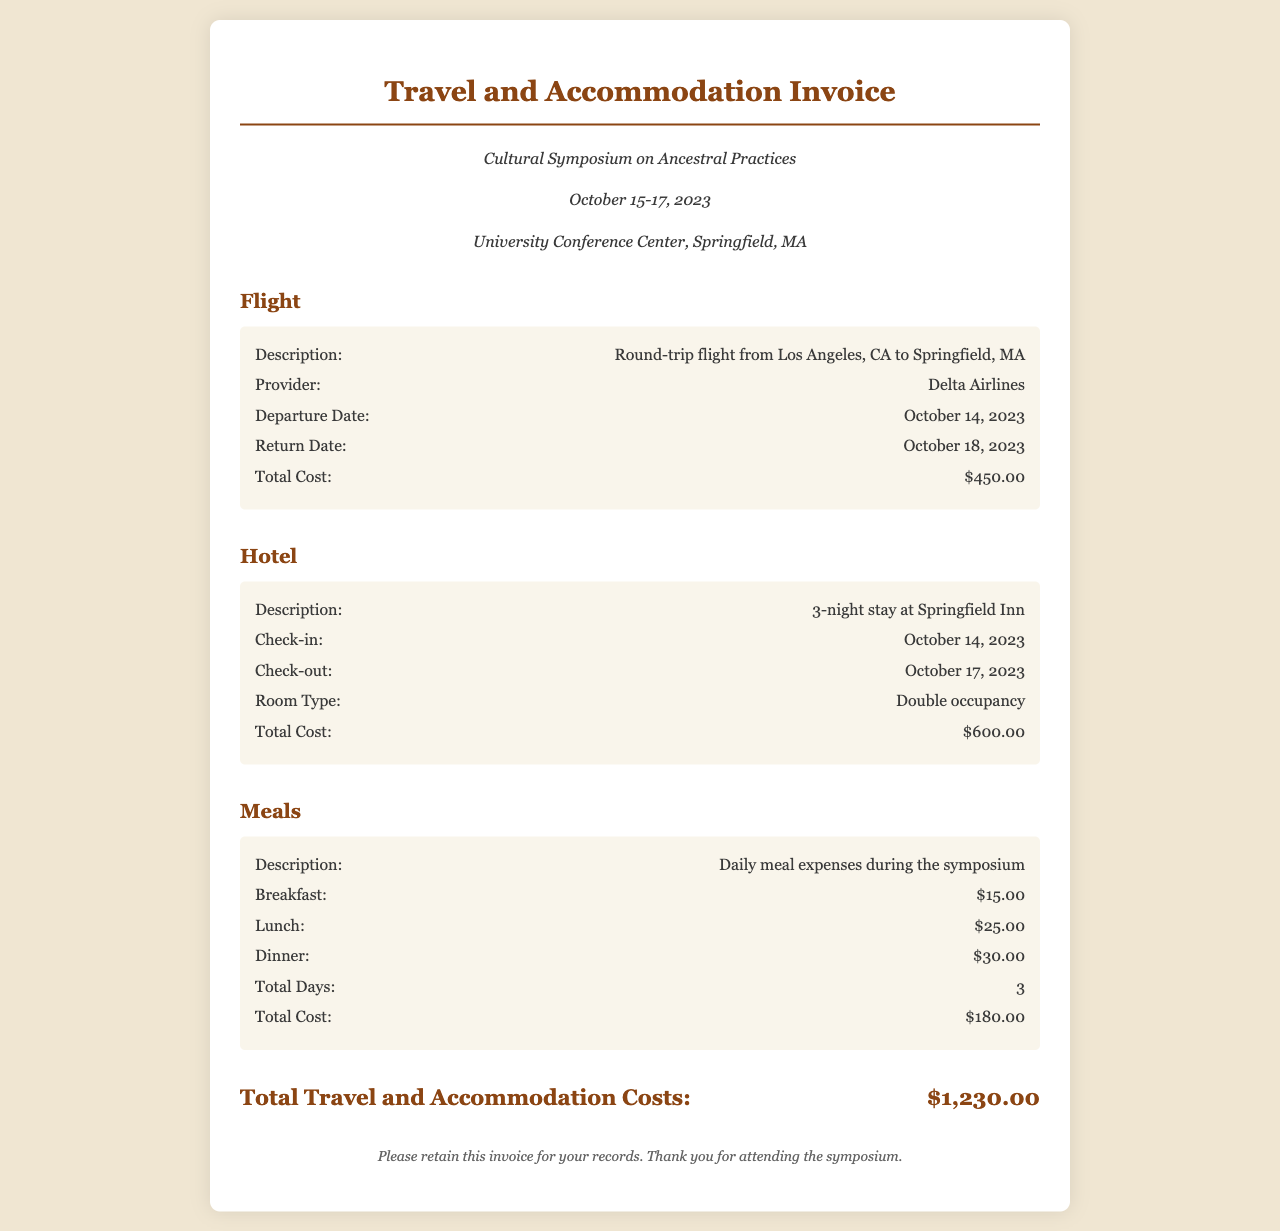What is the total cost of the round-trip flight? The total cost of the round-trip flight is provided under the Flight section of the document. It states the total cost is $450.00.
Answer: $450.00 What is the check-in date for the hotel stay? The check-in date for the hotel stay is listed under the Hotel section, which is October 14, 2023.
Answer: October 14, 2023 How many total days of meals are accounted for? The total days of meals can be found in the Meals section, which states there are 3 total days.
Answer: 3 What is the name of the airline? The airline name is specified under the Flight section of the document as Delta Airlines.
Answer: Delta Airlines What is the total cost for accommodation? The total cost for accommodation is provided in the Hotel section, which specifies the total is $600.00.
Answer: $600.00 What is the daily cost of dinner? The daily cost of dinner is mentioned in the Meals section, which indicates it is $30.00 per day.
Answer: $30.00 What is the total amount for travel and accommodation costs? The total amount for travel and accommodation costs is summarized at the end of the document, which states it is $1,230.00.
Answer: $1,230.00 When is the symposium taking place? The dates of the symposium are mentioned in the event details, which state it takes place from October 15-17, 2023.
Answer: October 15-17, 2023 What type of room was booked at the hotel? The type of room booked at the hotel is specified under the Hotel section as Double occupancy.
Answer: Double occupancy 